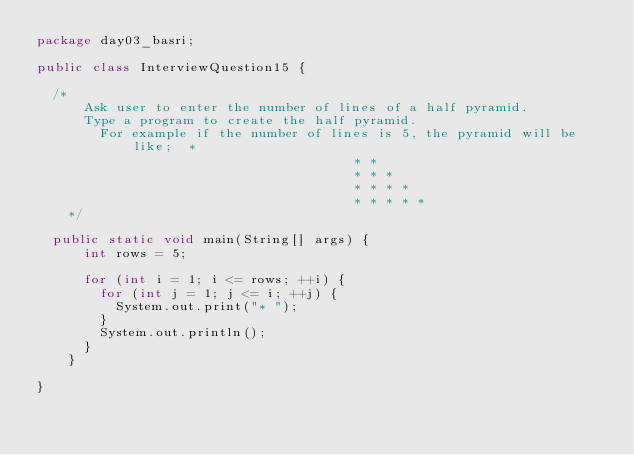Convert code to text. <code><loc_0><loc_0><loc_500><loc_500><_Java_>package day03_basri;

public class InterviewQuestion15 {
	
	/*
	  	Ask user to enter the number of lines of a half pyramid.
	  	Type a program to create the half pyramid.
  	    For example if the number of lines is 5, the pyramid will be like;  * 
																		    * * 
																		    * * * 
																		    * * * * 
																		    * * * * *
    */
	
	public static void main(String[] args) {
	    int rows = 5;

	    for (int i = 1; i <= rows; ++i) {
	      for (int j = 1; j <= i; ++j) {
	        System.out.print("* ");
	      }
	      System.out.println();
	    }
	  }

}
</code> 